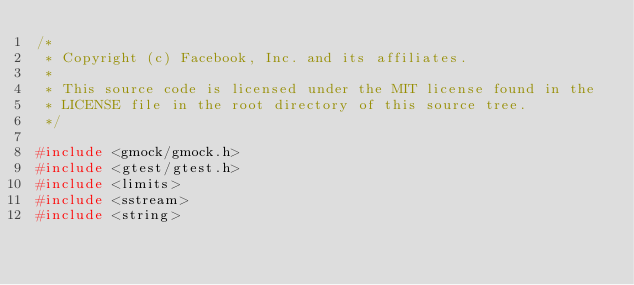Convert code to text. <code><loc_0><loc_0><loc_500><loc_500><_C++_>/*
 * Copyright (c) Facebook, Inc. and its affiliates.
 *
 * This source code is licensed under the MIT license found in the
 * LICENSE file in the root directory of this source tree.
 */

#include <gmock/gmock.h>
#include <gtest/gtest.h>
#include <limits>
#include <sstream>
#include <string></code> 